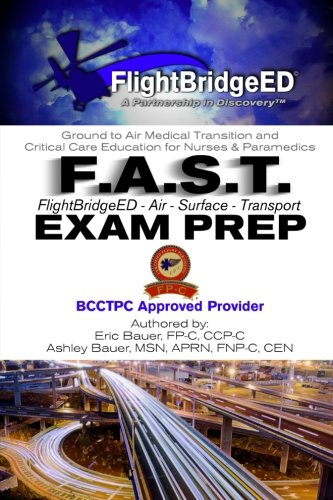What is the title of this book? The full title of this book is 'F.A.S.T Exam Prep: FlightBridgeED - Air - Surface - Transport - Exam - Prep', which comprehensively indicates its content is focused on preparing for exams related to air and surface medical transport. 